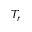Convert formula to latex. <formula><loc_0><loc_0><loc_500><loc_500>T _ { r }</formula> 